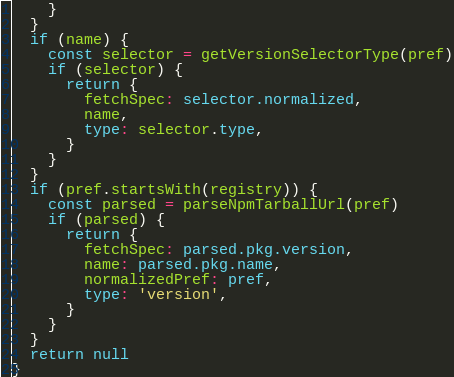<code> <loc_0><loc_0><loc_500><loc_500><_TypeScript_>    }
  }
  if (name) {
    const selector = getVersionSelectorType(pref)
    if (selector) {
      return {
        fetchSpec: selector.normalized,
        name,
        type: selector.type,
      }
    }
  }
  if (pref.startsWith(registry)) {
    const parsed = parseNpmTarballUrl(pref)
    if (parsed) {
      return {
        fetchSpec: parsed.pkg.version,
        name: parsed.pkg.name,
        normalizedPref: pref,
        type: 'version',
      }
    }
  }
  return null
}
</code> 